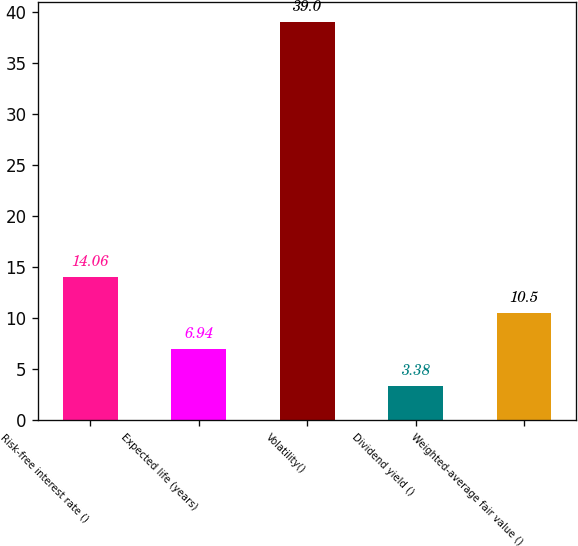Convert chart to OTSL. <chart><loc_0><loc_0><loc_500><loc_500><bar_chart><fcel>Risk-free interest rate ()<fcel>Expected life (years)<fcel>Volatility()<fcel>Dividend yield ()<fcel>Weighted-average fair value ()<nl><fcel>14.06<fcel>6.94<fcel>39<fcel>3.38<fcel>10.5<nl></chart> 